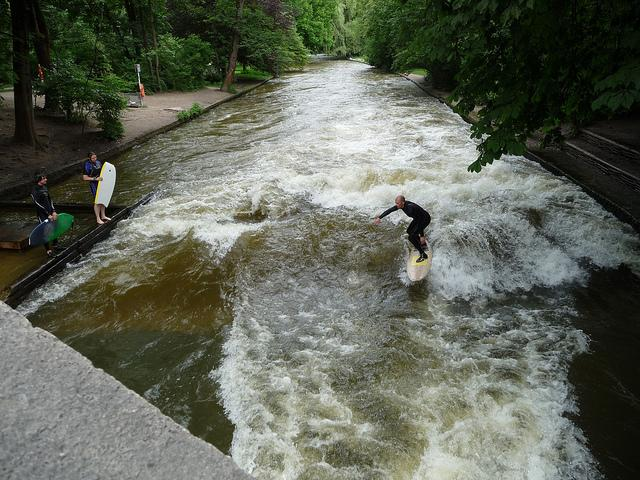Tidal bores surfing can be played on which water? river 